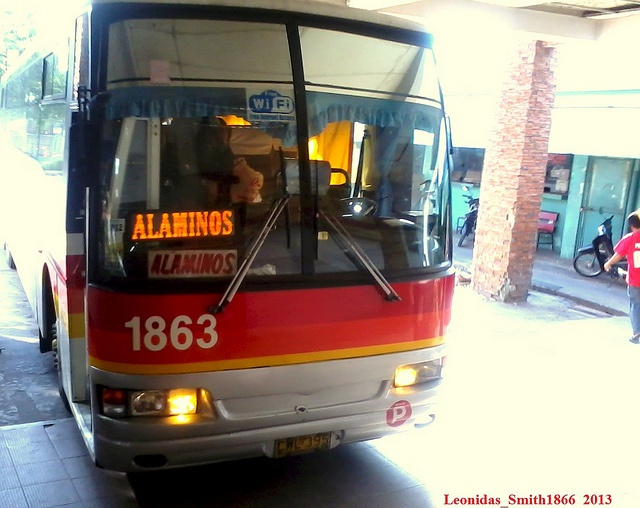Describe the objects in this image and their specific colors. I can see bus in lightyellow, black, gray, beige, and maroon tones, people in lightyellow, black, maroon, and brown tones, people in beige, salmon, white, gray, and violet tones, motorcycle in lightyellow, navy, gray, and darkgray tones, and motorcycle in lightyellow, turquoise, gray, and blue tones in this image. 